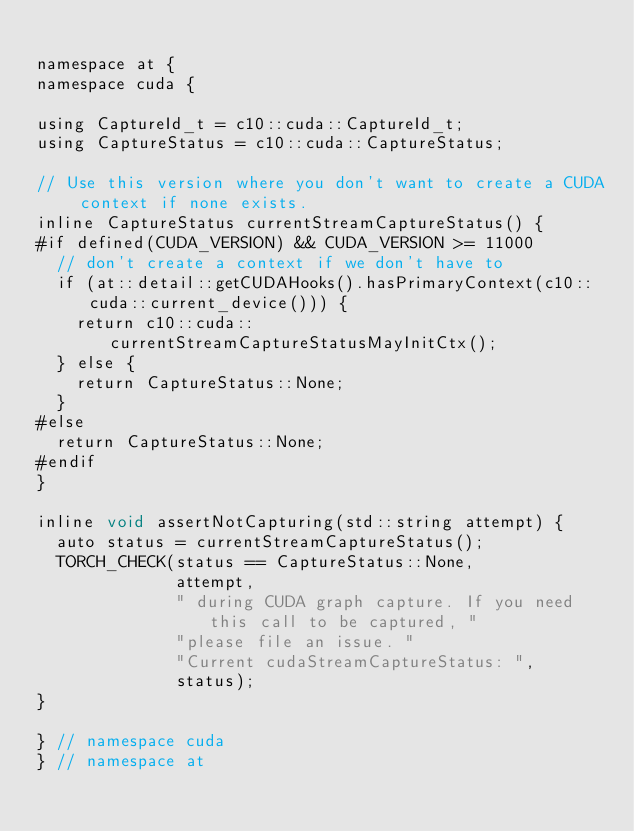<code> <loc_0><loc_0><loc_500><loc_500><_Cuda_>
namespace at {
namespace cuda {

using CaptureId_t = c10::cuda::CaptureId_t;
using CaptureStatus = c10::cuda::CaptureStatus;

// Use this version where you don't want to create a CUDA context if none exists.
inline CaptureStatus currentStreamCaptureStatus() {
#if defined(CUDA_VERSION) && CUDA_VERSION >= 11000
  // don't create a context if we don't have to
  if (at::detail::getCUDAHooks().hasPrimaryContext(c10::cuda::current_device())) {
    return c10::cuda::currentStreamCaptureStatusMayInitCtx();
  } else {
    return CaptureStatus::None;
  }
#else
  return CaptureStatus::None;
#endif
}

inline void assertNotCapturing(std::string attempt) {
  auto status = currentStreamCaptureStatus();
  TORCH_CHECK(status == CaptureStatus::None,
              attempt,
              " during CUDA graph capture. If you need this call to be captured, "
              "please file an issue. "
              "Current cudaStreamCaptureStatus: ",
              status);
}

} // namespace cuda
} // namespace at
</code> 